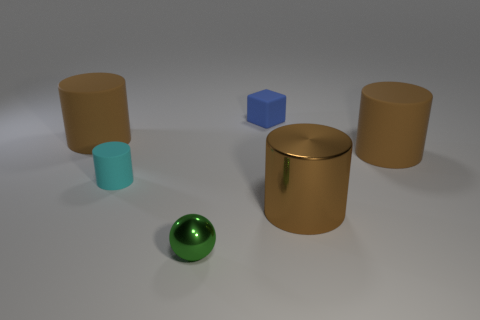What number of matte things are the same color as the metallic cylinder?
Provide a succinct answer. 2. There is a blue rubber thing that is on the left side of the big thing in front of the tiny rubber cylinder; how big is it?
Your answer should be very brief. Small. What number of things are brown cylinders that are right of the small rubber cube or purple rubber cylinders?
Keep it short and to the point. 2. Are there any other cylinders of the same size as the metal cylinder?
Ensure brevity in your answer.  Yes. There is a metallic object that is right of the tiny blue block; is there a cylinder that is behind it?
Your response must be concise. Yes. How many blocks are small blue matte things or big brown matte objects?
Offer a very short reply. 1. Is there a tiny blue thing that has the same shape as the small cyan thing?
Your answer should be very brief. No. The green shiny thing is what shape?
Keep it short and to the point. Sphere. What number of things are either large brown matte objects or big purple rubber spheres?
Provide a succinct answer. 2. Do the brown cylinder on the left side of the blue rubber thing and the brown matte cylinder that is on the right side of the tiny green metallic ball have the same size?
Keep it short and to the point. Yes. 